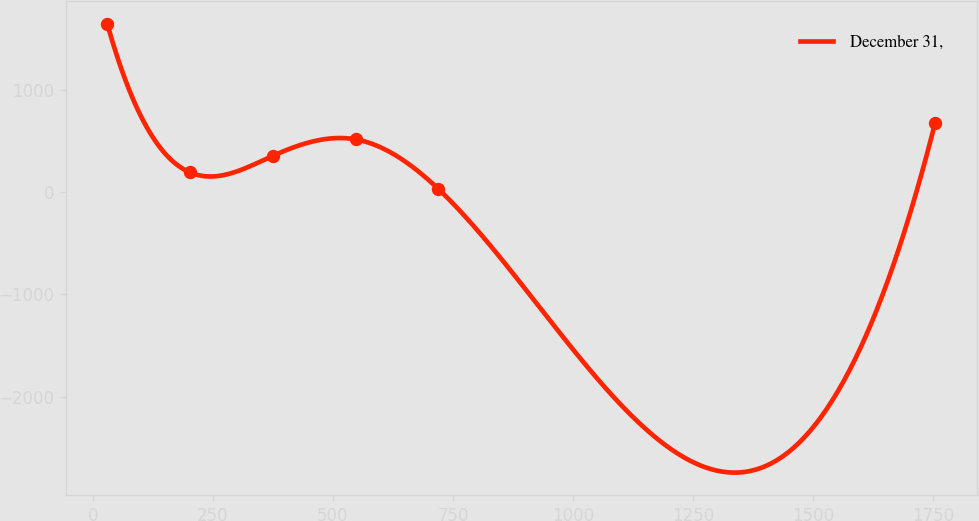Convert chart. <chart><loc_0><loc_0><loc_500><loc_500><line_chart><ecel><fcel>December 31,<nl><fcel>29.74<fcel>1646.43<nl><fcel>202.21<fcel>192.7<nl><fcel>374.68<fcel>354.23<nl><fcel>547.15<fcel>515.76<nl><fcel>719.62<fcel>31.17<nl><fcel>1754.4<fcel>677.29<nl></chart> 